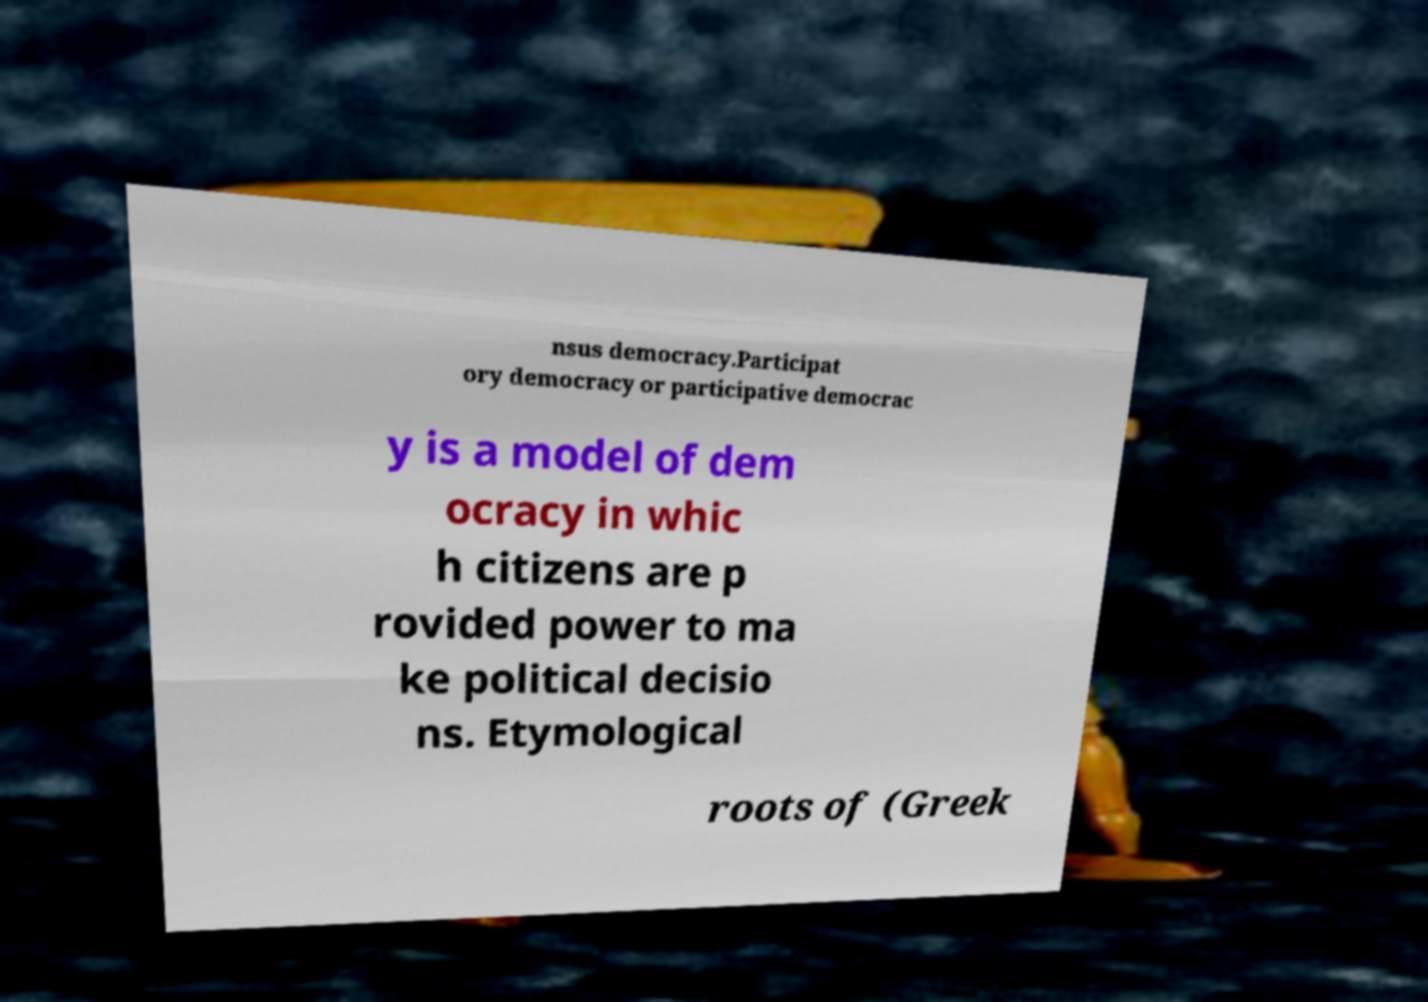Please read and relay the text visible in this image. What does it say? nsus democracy.Participat ory democracy or participative democrac y is a model of dem ocracy in whic h citizens are p rovided power to ma ke political decisio ns. Etymological roots of (Greek 